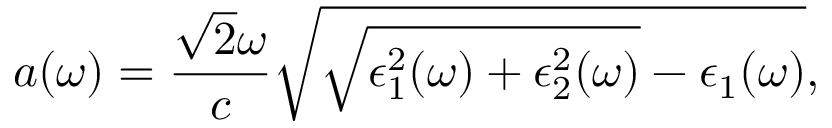<formula> <loc_0><loc_0><loc_500><loc_500>a ( \omega ) = \frac { \sqrt { 2 } \omega } { c } \sqrt { \sqrt { \epsilon _ { 1 } ^ { 2 } ( \omega ) + \epsilon _ { 2 } ^ { 2 } ( \omega ) } - \epsilon _ { 1 } ( \omega ) } ,</formula> 